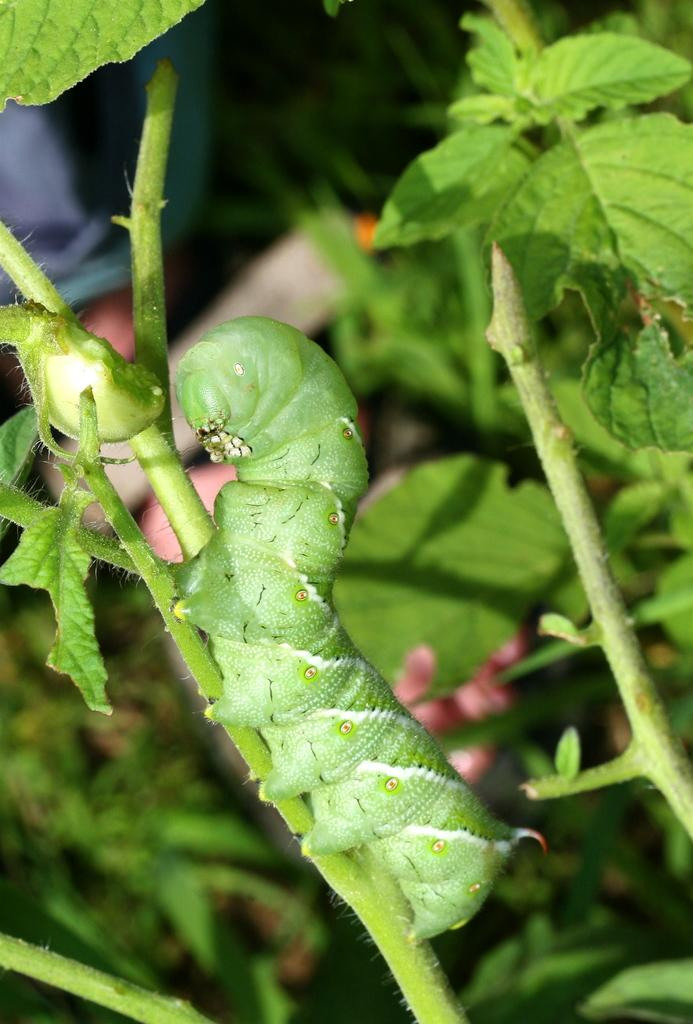What is located in the foreground of the picture? There is a plant in the foreground of the picture. What are the main parts of the plant? The plant has leaves and a stem. Is there any other living organism on the plant? Yes, there is a caterpillar on the plant. How would you describe the background of the image? The background of the image is blurred. What type of behavior does the girl exhibit in the image? There is no girl present in the image; it features a plant with a caterpillar on it. 